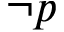Convert formula to latex. <formula><loc_0><loc_0><loc_500><loc_500>\neg p</formula> 